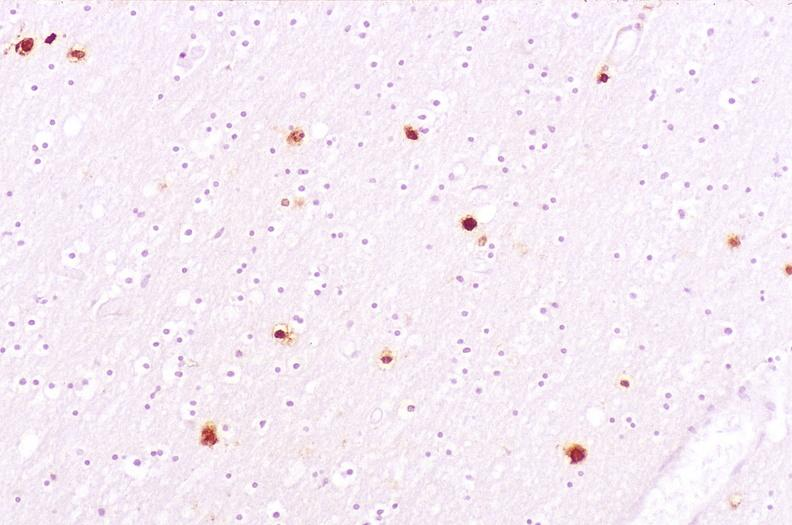do immunoperoxidate stain?
Answer the question using a single word or phrase. Yes 